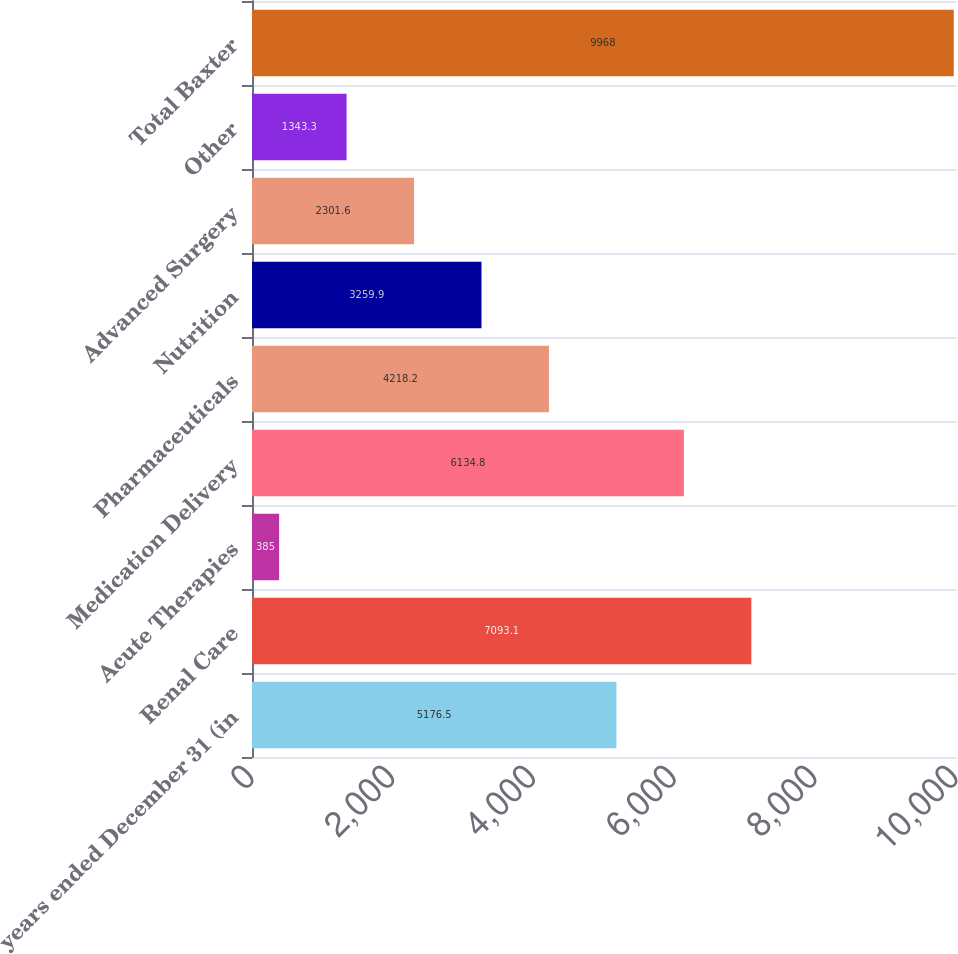Convert chart. <chart><loc_0><loc_0><loc_500><loc_500><bar_chart><fcel>years ended December 31 (in<fcel>Renal Care<fcel>Acute Therapies<fcel>Medication Delivery<fcel>Pharmaceuticals<fcel>Nutrition<fcel>Advanced Surgery<fcel>Other<fcel>Total Baxter<nl><fcel>5176.5<fcel>7093.1<fcel>385<fcel>6134.8<fcel>4218.2<fcel>3259.9<fcel>2301.6<fcel>1343.3<fcel>9968<nl></chart> 